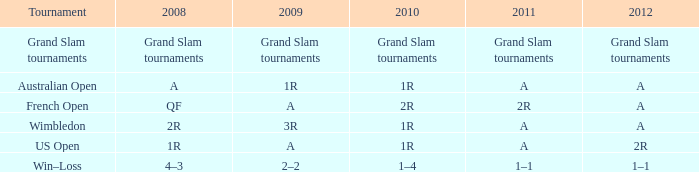Name the 2010 for tournament of us open 1R. 